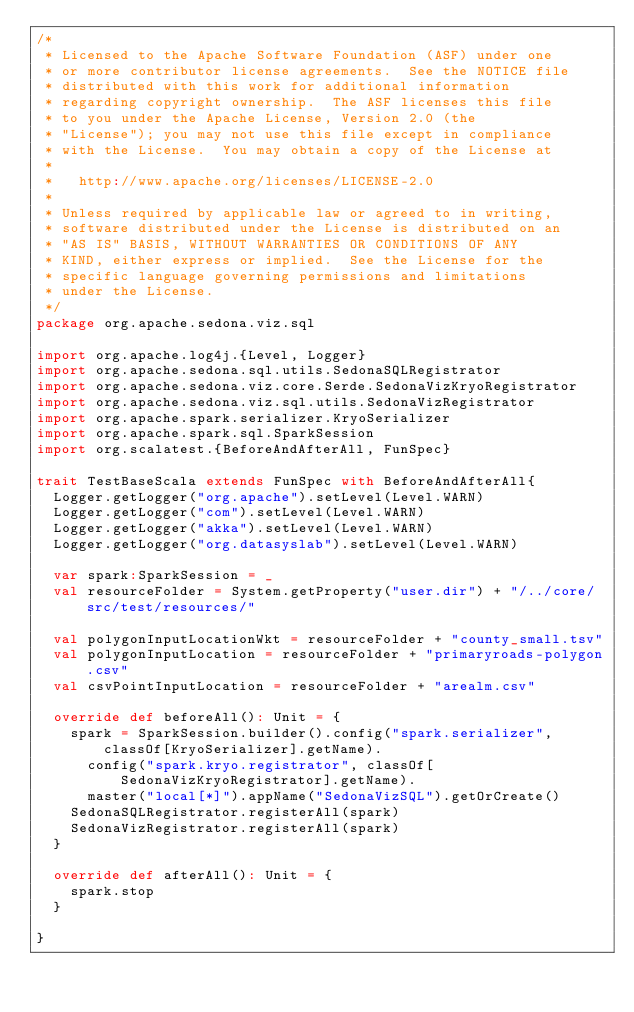<code> <loc_0><loc_0><loc_500><loc_500><_Scala_>/*
 * Licensed to the Apache Software Foundation (ASF) under one
 * or more contributor license agreements.  See the NOTICE file
 * distributed with this work for additional information
 * regarding copyright ownership.  The ASF licenses this file
 * to you under the Apache License, Version 2.0 (the
 * "License"); you may not use this file except in compliance
 * with the License.  You may obtain a copy of the License at
 *
 *   http://www.apache.org/licenses/LICENSE-2.0
 *
 * Unless required by applicable law or agreed to in writing,
 * software distributed under the License is distributed on an
 * "AS IS" BASIS, WITHOUT WARRANTIES OR CONDITIONS OF ANY
 * KIND, either express or implied.  See the License for the
 * specific language governing permissions and limitations
 * under the License.
 */
package org.apache.sedona.viz.sql

import org.apache.log4j.{Level, Logger}
import org.apache.sedona.sql.utils.SedonaSQLRegistrator
import org.apache.sedona.viz.core.Serde.SedonaVizKryoRegistrator
import org.apache.sedona.viz.sql.utils.SedonaVizRegistrator
import org.apache.spark.serializer.KryoSerializer
import org.apache.spark.sql.SparkSession
import org.scalatest.{BeforeAndAfterAll, FunSpec}

trait TestBaseScala extends FunSpec with BeforeAndAfterAll{
  Logger.getLogger("org.apache").setLevel(Level.WARN)
  Logger.getLogger("com").setLevel(Level.WARN)
  Logger.getLogger("akka").setLevel(Level.WARN)
  Logger.getLogger("org.datasyslab").setLevel(Level.WARN)

  var spark:SparkSession = _
  val resourceFolder = System.getProperty("user.dir") + "/../core/src/test/resources/"

  val polygonInputLocationWkt = resourceFolder + "county_small.tsv"
  val polygonInputLocation = resourceFolder + "primaryroads-polygon.csv"
  val csvPointInputLocation = resourceFolder + "arealm.csv"

  override def beforeAll(): Unit = {
    spark = SparkSession.builder().config("spark.serializer", classOf[KryoSerializer].getName).
      config("spark.kryo.registrator", classOf[SedonaVizKryoRegistrator].getName).
      master("local[*]").appName("SedonaVizSQL").getOrCreate()
    SedonaSQLRegistrator.registerAll(spark)
    SedonaVizRegistrator.registerAll(spark)
  }

  override def afterAll(): Unit = {
    spark.stop
  }

}
</code> 